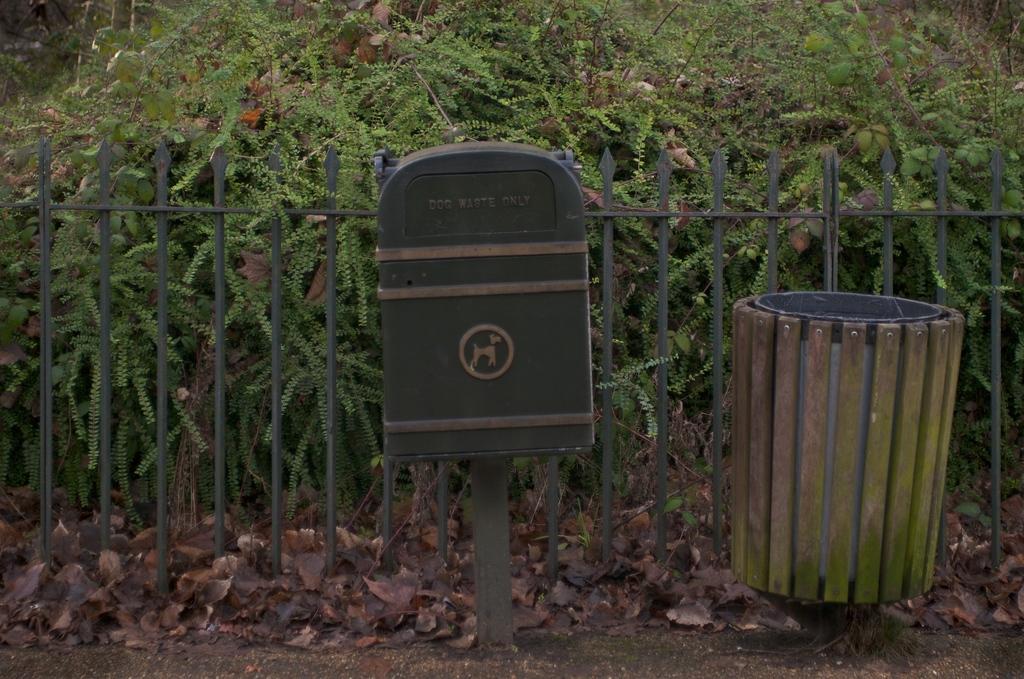What kind of waste is the trash can for?
Make the answer very short. Dog waste. 